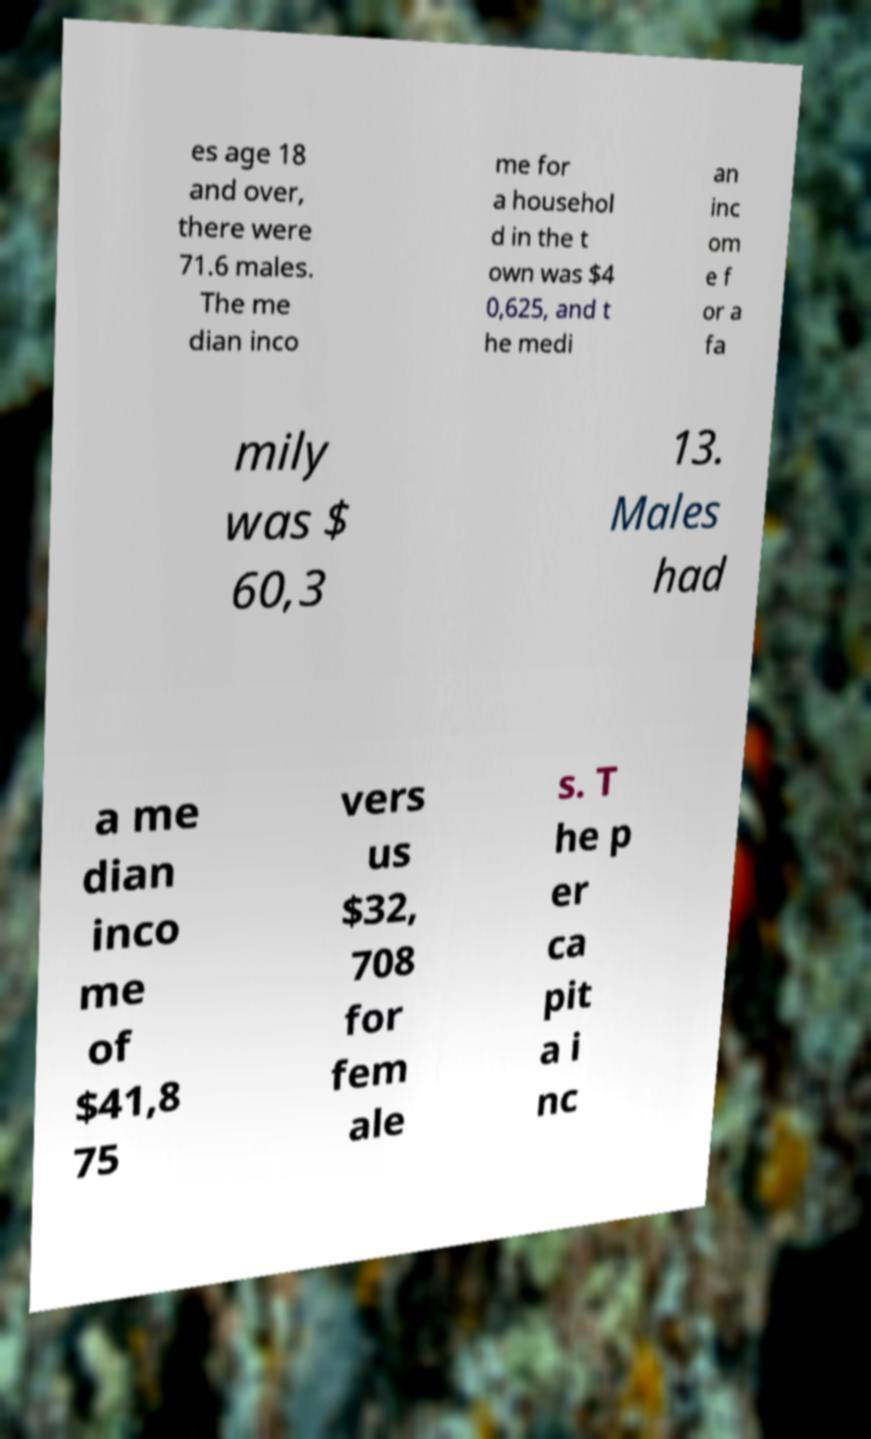Could you extract and type out the text from this image? es age 18 and over, there were 71.6 males. The me dian inco me for a househol d in the t own was $4 0,625, and t he medi an inc om e f or a fa mily was $ 60,3 13. Males had a me dian inco me of $41,8 75 vers us $32, 708 for fem ale s. T he p er ca pit a i nc 